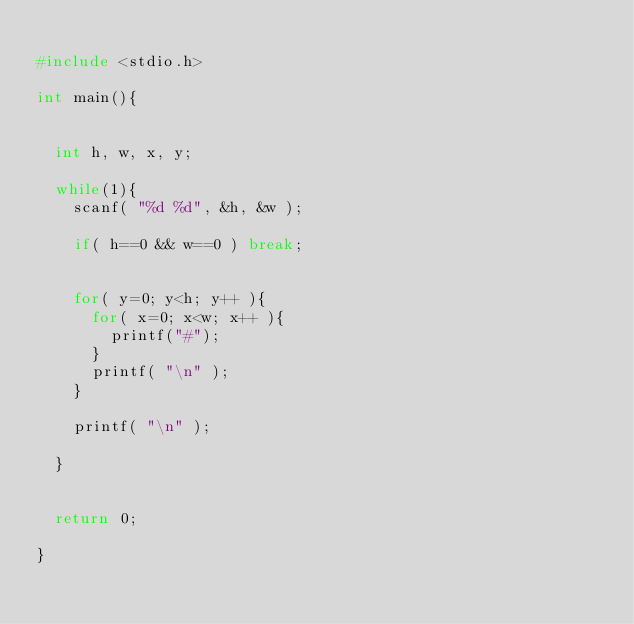<code> <loc_0><loc_0><loc_500><loc_500><_C_>
#include <stdio.h>

int main(){


	int h, w, x, y;

	while(1){
		scanf( "%d %d", &h, &w );

		if( h==0 && w==0 ) break;


		for( y=0; y<h; y++ ){
			for( x=0; x<w; x++ ){
				printf("#");
			}
			printf( "\n" );
		}
		
		printf( "\n" );

	}


	return 0;

}</code> 